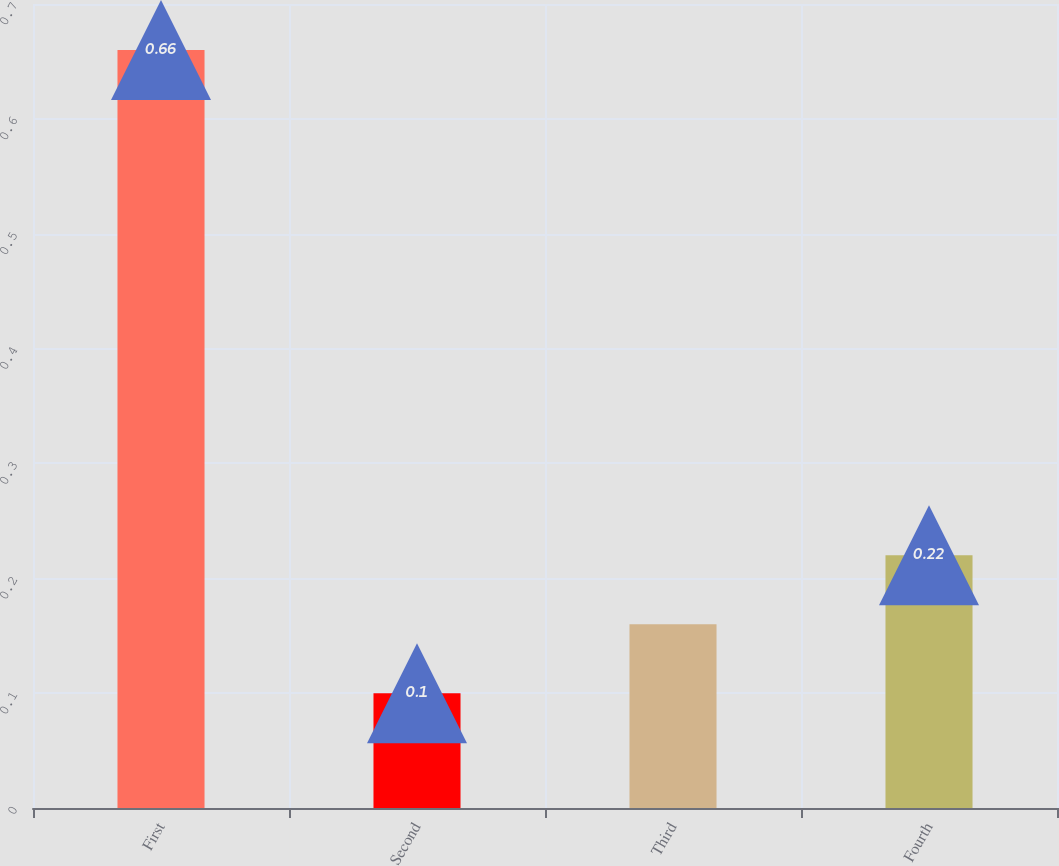Convert chart to OTSL. <chart><loc_0><loc_0><loc_500><loc_500><bar_chart><fcel>First<fcel>Second<fcel>Third<fcel>Fourth<nl><fcel>0.66<fcel>0.1<fcel>0.16<fcel>0.22<nl></chart> 